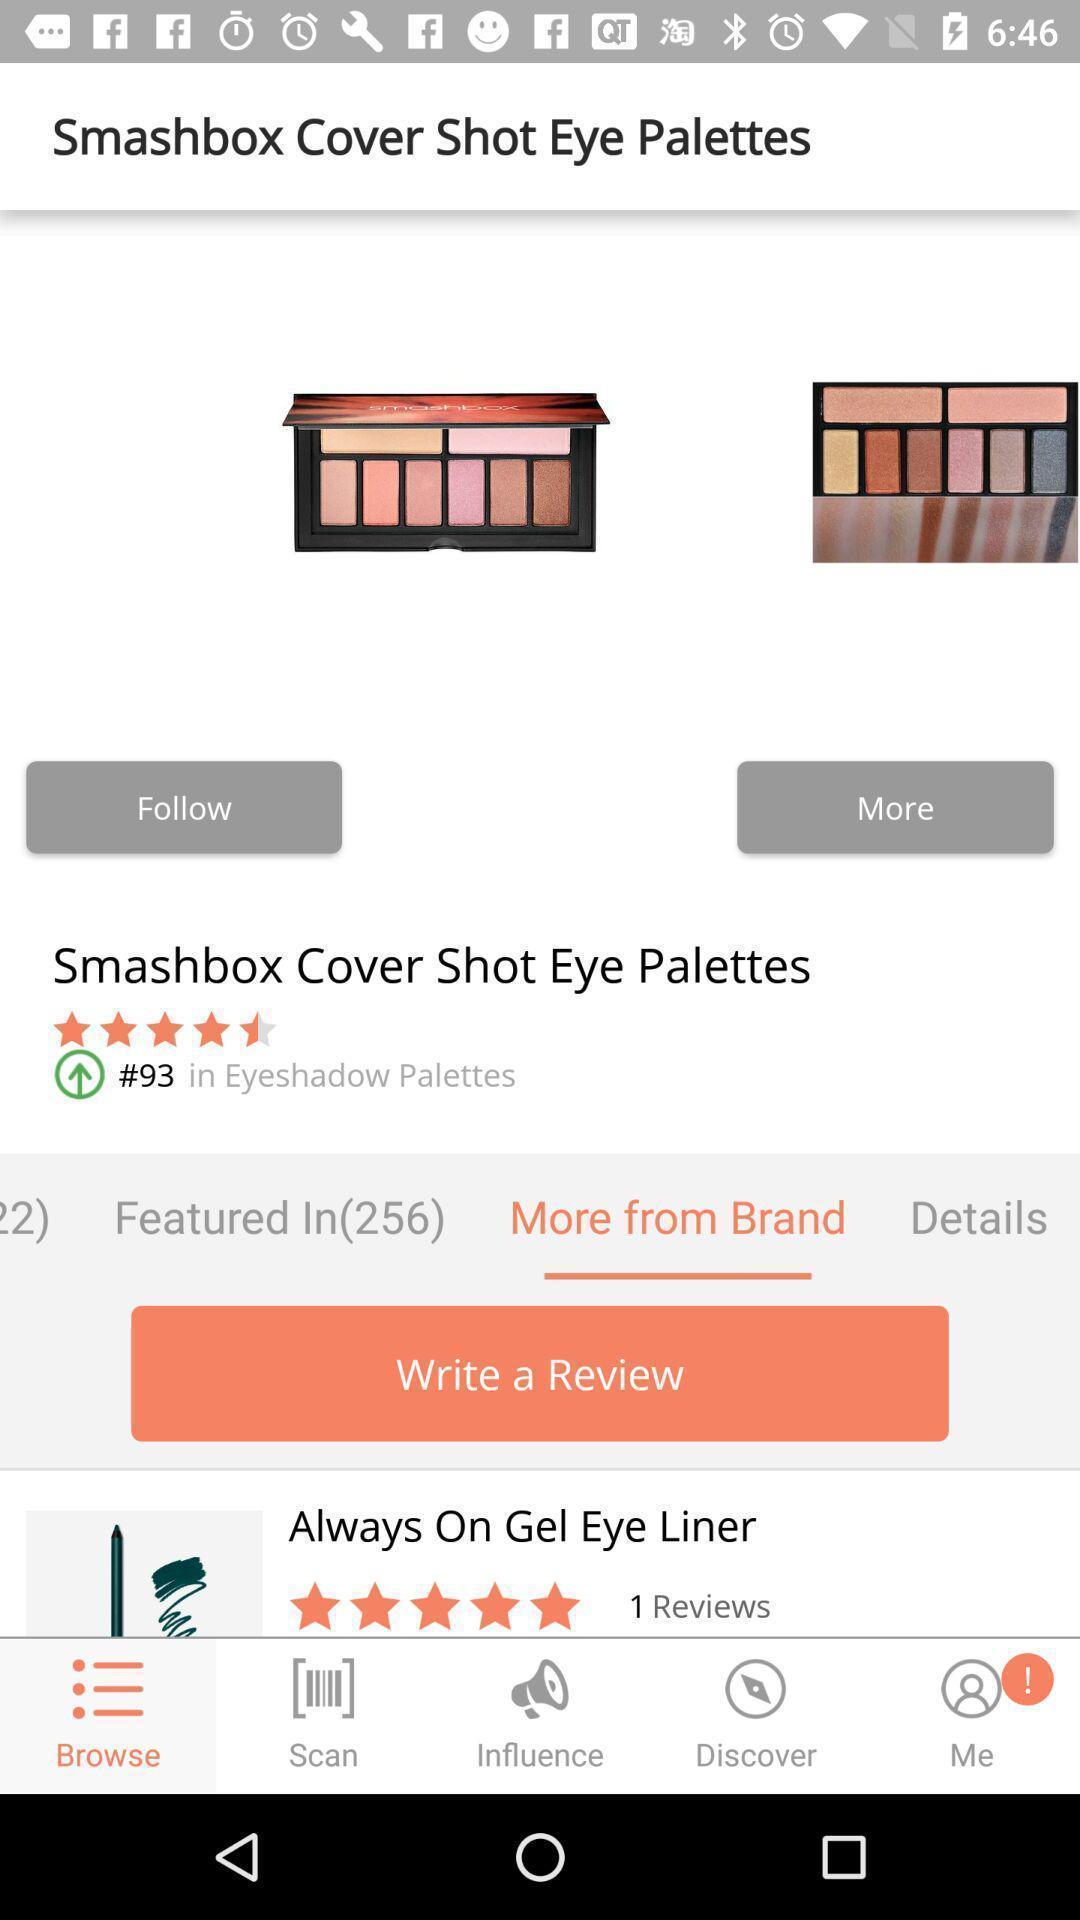Provide a detailed account of this screenshot. Shopping page giving information of a product. 